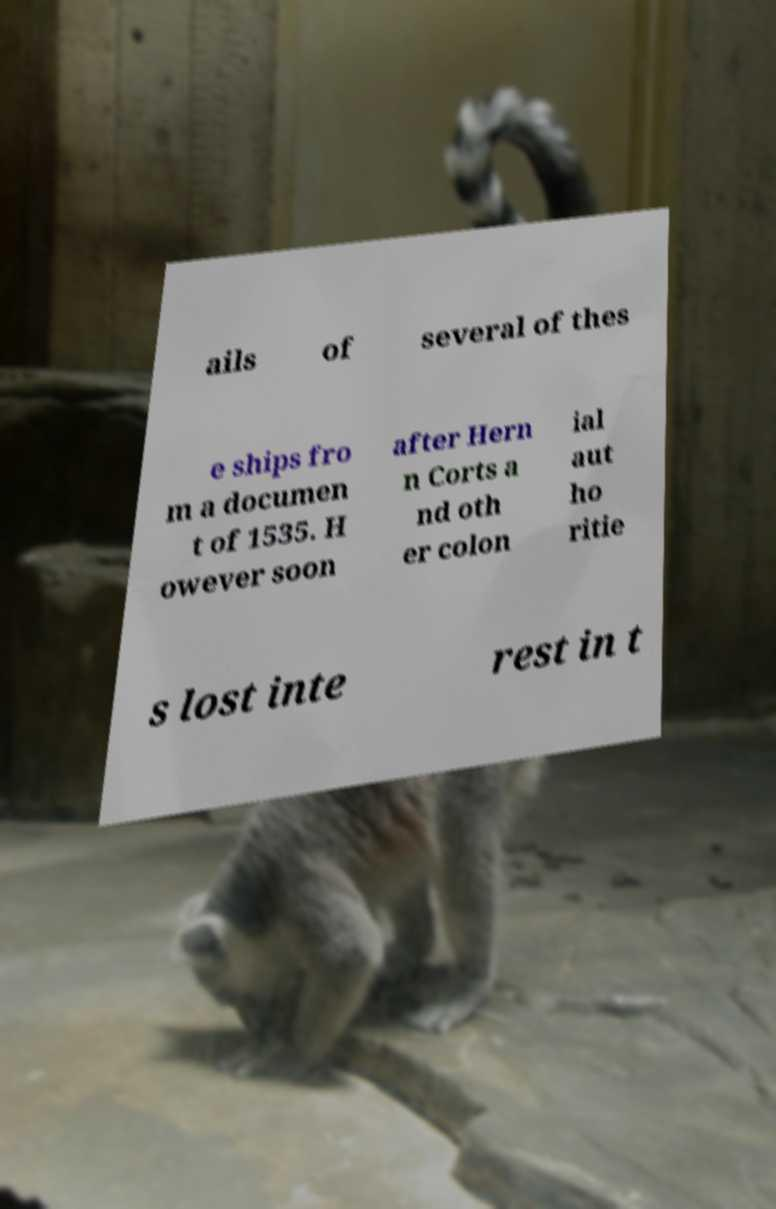For documentation purposes, I need the text within this image transcribed. Could you provide that? ails of several of thes e ships fro m a documen t of 1535. H owever soon after Hern n Corts a nd oth er colon ial aut ho ritie s lost inte rest in t 